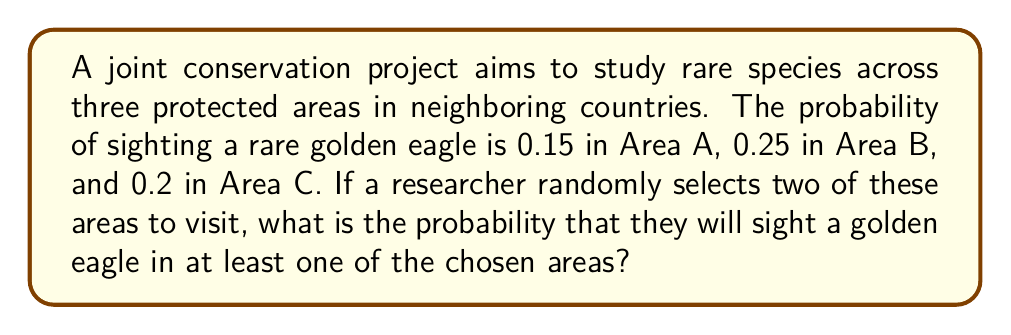Can you answer this question? Let's approach this step-by-step:

1) First, we need to calculate the probability of selecting any two areas out of the three. There are three possible combinations: (A,B), (A,C), and (B,C). Each combination has an equal probability of $\frac{1}{3}$.

2) For each combination, we need to calculate the probability of sighting a golden eagle in at least one of the two areas. We can do this by calculating the probability of not sighting an eagle in either area and subtracting it from 1.

3) For combination (A,B):
   $P(\text{eagle in A or B}) = 1 - P(\text{no eagle in A and no eagle in B})$
   $= 1 - (1-0.15)(1-0.25) = 1 - 0.85 \times 0.75 = 1 - 0.6375 = 0.3625$

4) For combination (A,C):
   $P(\text{eagle in A or C}) = 1 - (1-0.15)(1-0.2) = 1 - 0.85 \times 0.8 = 1 - 0.68 = 0.32$

5) For combination (B,C):
   $P(\text{eagle in B or C}) = 1 - (1-0.25)(1-0.2) = 1 - 0.75 \times 0.8 = 1 - 0.6 = 0.4$

6) The total probability is the sum of the probabilities for each combination, each multiplied by $\frac{1}{3}$:

   $P(\text{eagle in at least one area}) = \frac{1}{3}(0.3625 + 0.32 + 0.4)$
   
   $= \frac{1}{3} \times 1.0825 = 0.360833$

7) Rounding to three decimal places, we get 0.361 or 36.1%.
Answer: 0.361 or 36.1% 